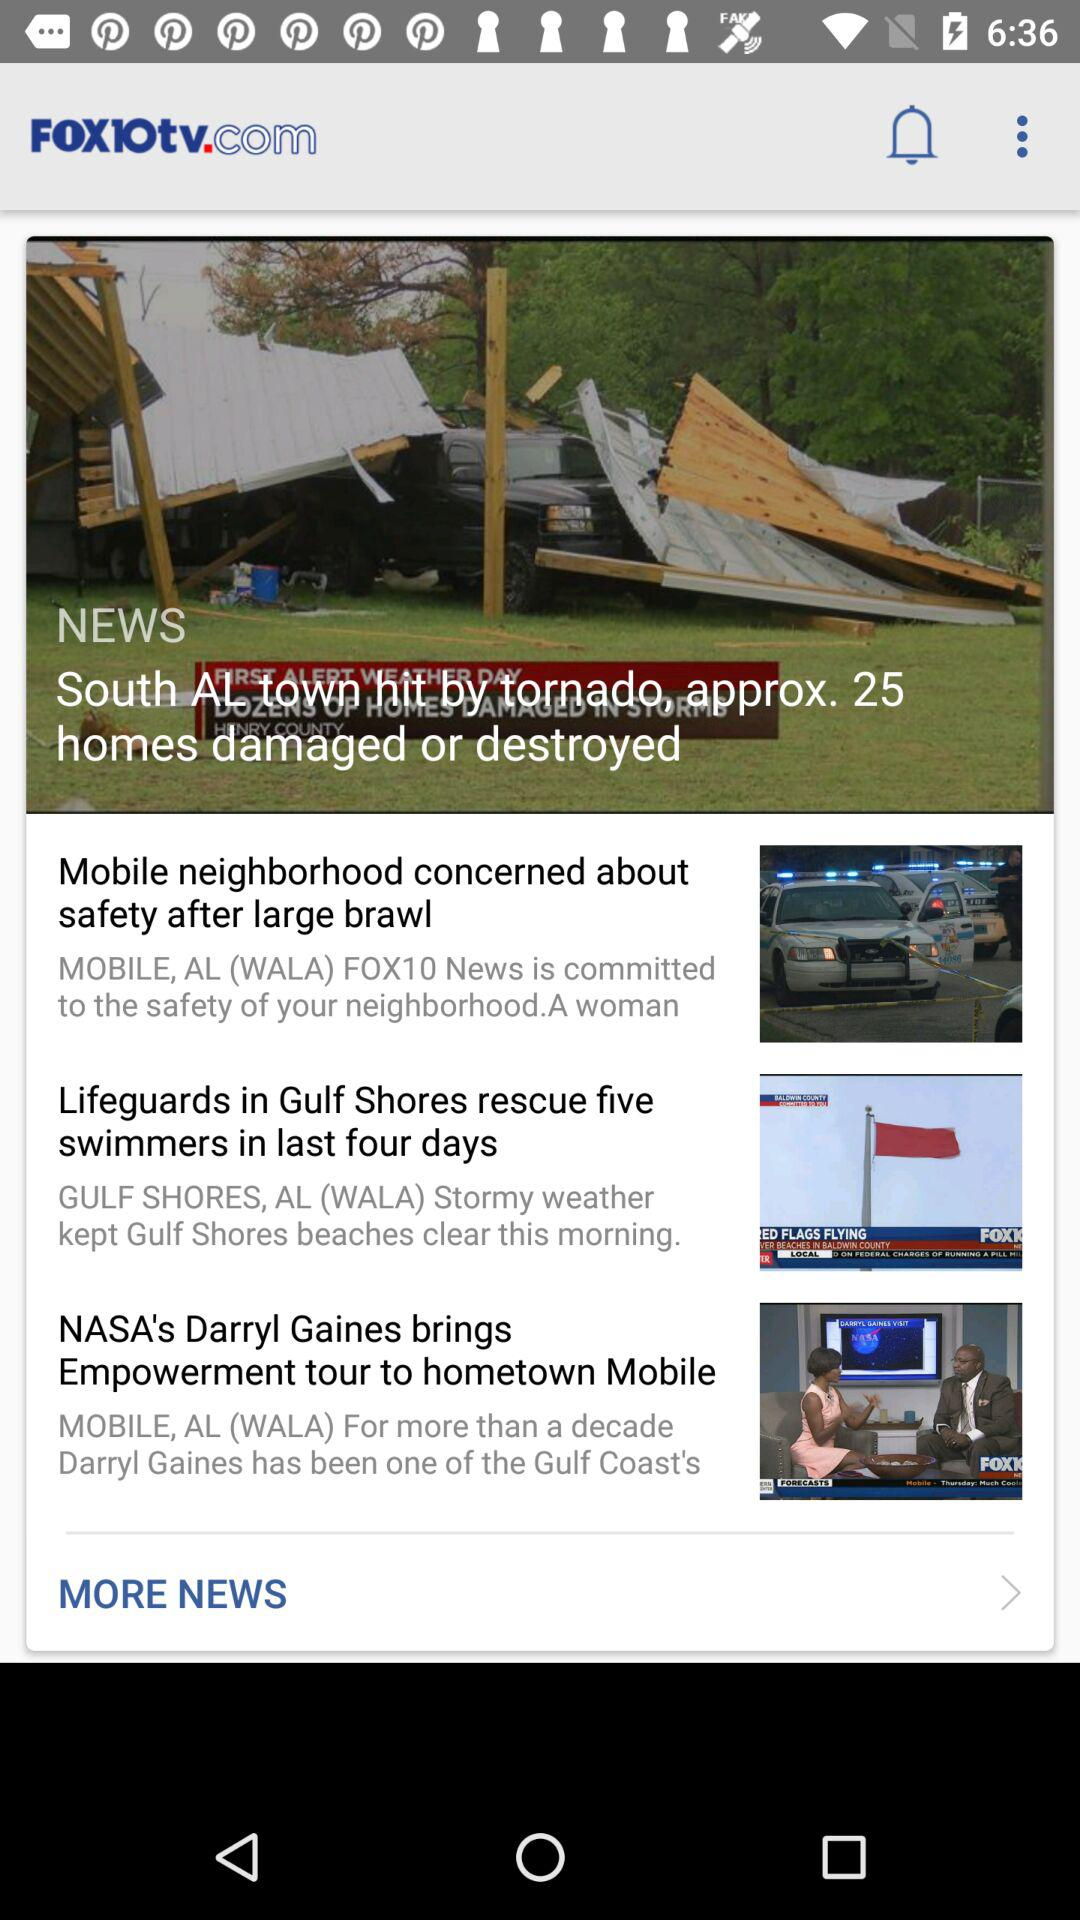Which headlines were flashed on top of the screen? The headline that was flashed on top of the screen was "South Al town hit by tornado, approx. 25 homes damaged or destroyed". 